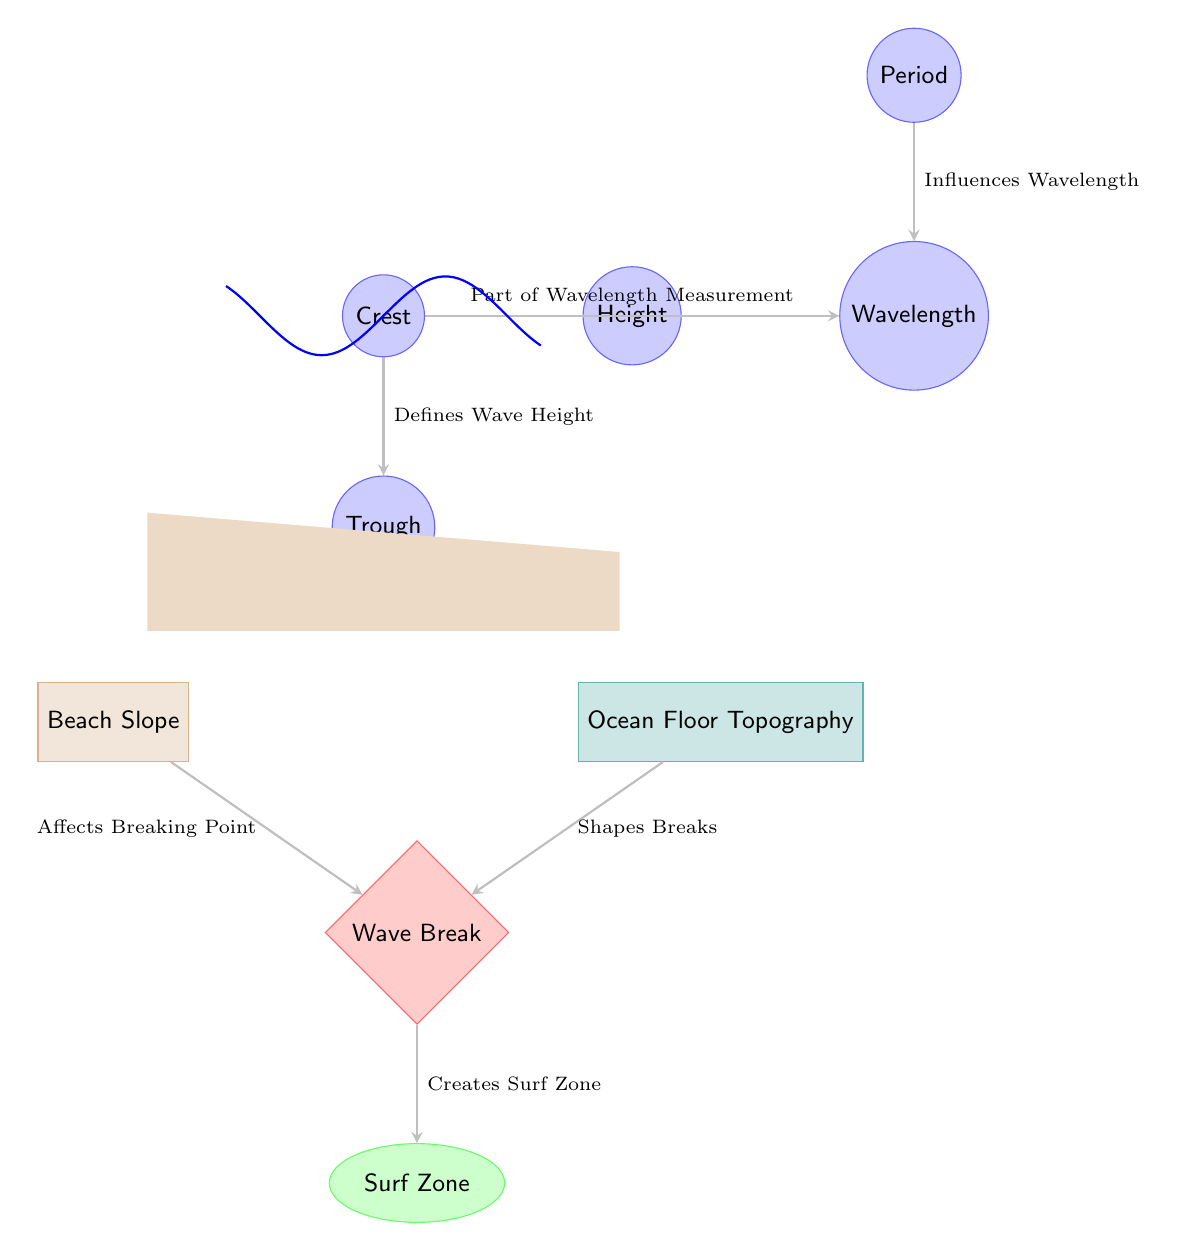What is the height of the wave? The height of the wave is defined by the distance between the crest and the trough. In the diagram, this value is labeled as "Height."
Answer: Height What affects the breaking point of the wave? The wave breaking point is influenced by the slope of the beach, as indicated by the arrow connecting "Beach Slope" to "Wave Break."
Answer: Beach Slope What is the role of the ocean floor in wave formation? The ocean floor's topography shapes the breaks of the waves, as mentioned by the arrow connecting "Ocean Floor Topography" to "Wave Break."
Answer: Shapes Breaks How does wave period influence the wavelength? The diagram shows that the wave period influences the wavelength, as indicated by the arrow from "Period" to "Wavelength."
Answer: Influences Wavelength What defines the surf zone? The surf zone is created by the wave breaking, which is shown by the arrow from "Wave Break" to "Surf Zone."
Answer: Creates Surf Zone What is the distance between the crest and trough? The distance between the crest and trough represents the wave height and is indicated in the diagram under the label "Height."
Answer: Wave Height What part of the measurement is the crest associated with? The crest is part of the wavelength measurement, as indicated by the arrow from "Crest" to "Wavelength."
Answer: Part of Wavelength Measurement How many nodes are there in the diagram? Counting all the visual elements representing different aspects of the wave and its impact on the beach leads to a total of eight nodes.
Answer: Eight Nodes What color represents the surf zone? The surf zone is depicted in green, as highlighted in the "Surf Zone" node of the diagram.
Answer: Green 